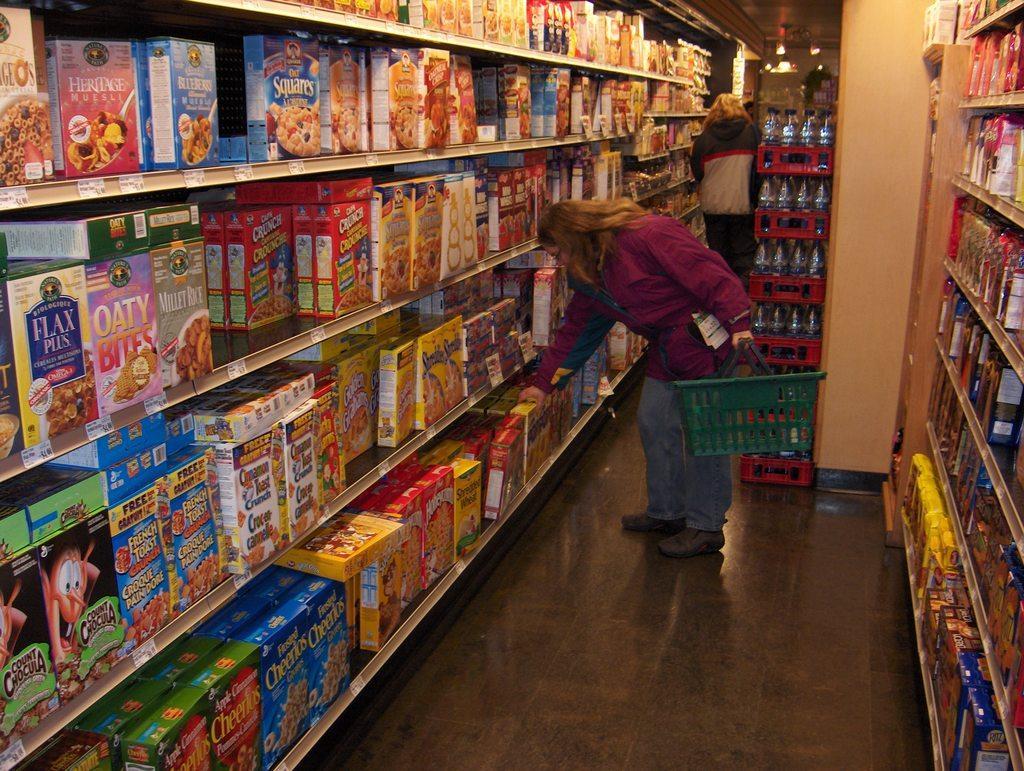Could you give a brief overview of what you see in this image? The image is taken in the store. In the center of the image there is a lady standing and holding a basket and there are goods placed in the shelves. In the background there are racks and we can see a person. At the top there are lights. 